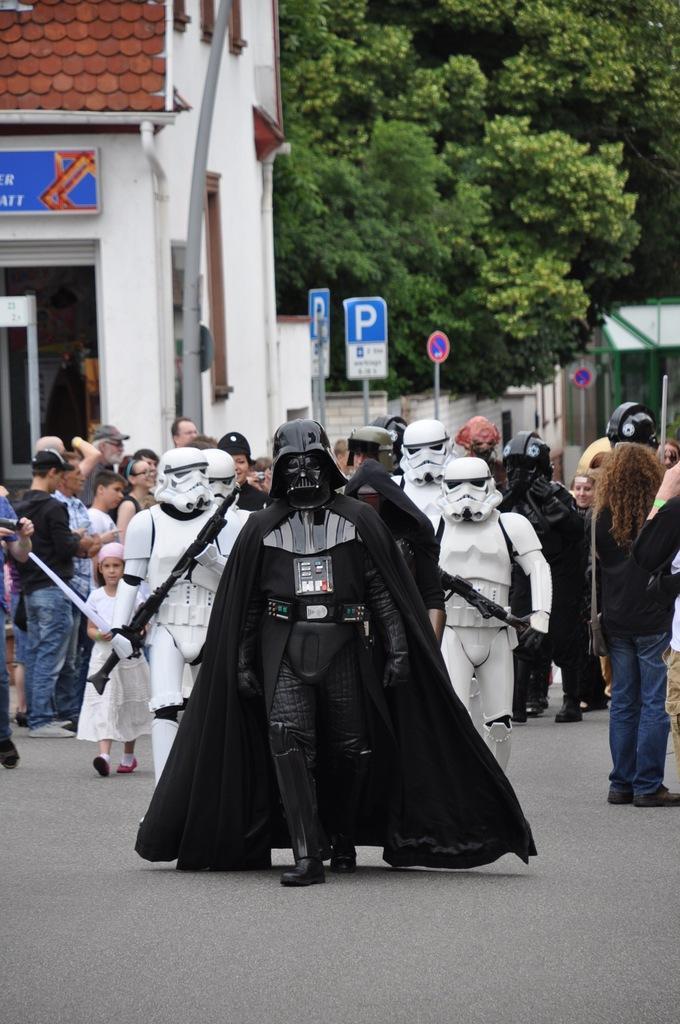In one or two sentences, can you explain what this image depicts? In this image we can see so many people. In the background, we can see sign boards, buildings and trees. At the bottom of the image, we can see the road. 